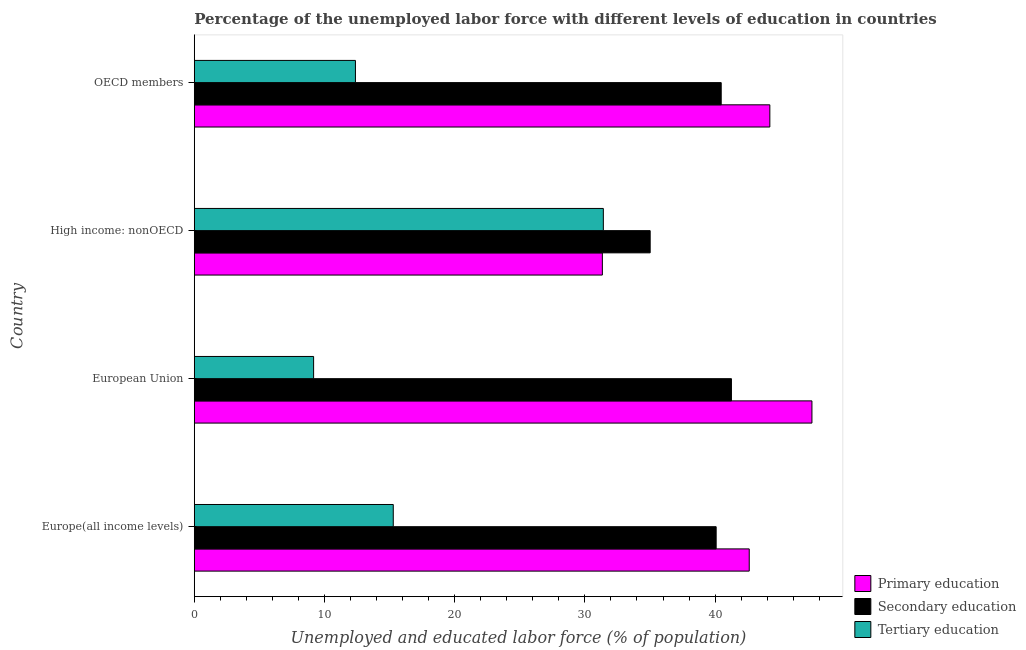How many groups of bars are there?
Ensure brevity in your answer.  4. Are the number of bars per tick equal to the number of legend labels?
Offer a very short reply. Yes. Are the number of bars on each tick of the Y-axis equal?
Provide a succinct answer. Yes. How many bars are there on the 4th tick from the bottom?
Make the answer very short. 3. What is the label of the 3rd group of bars from the top?
Your response must be concise. European Union. In how many cases, is the number of bars for a given country not equal to the number of legend labels?
Provide a succinct answer. 0. What is the percentage of labor force who received primary education in European Union?
Make the answer very short. 47.44. Across all countries, what is the maximum percentage of labor force who received secondary education?
Ensure brevity in your answer.  41.26. Across all countries, what is the minimum percentage of labor force who received primary education?
Ensure brevity in your answer.  31.34. In which country was the percentage of labor force who received tertiary education maximum?
Ensure brevity in your answer.  High income: nonOECD. In which country was the percentage of labor force who received secondary education minimum?
Provide a succinct answer. High income: nonOECD. What is the total percentage of labor force who received secondary education in the graph?
Offer a terse response. 156.83. What is the difference between the percentage of labor force who received tertiary education in European Union and that in OECD members?
Your answer should be very brief. -3.21. What is the difference between the percentage of labor force who received secondary education in Europe(all income levels) and the percentage of labor force who received tertiary education in European Union?
Your answer should be compact. 30.92. What is the average percentage of labor force who received primary education per country?
Provide a succinct answer. 41.4. What is the difference between the percentage of labor force who received secondary education and percentage of labor force who received primary education in OECD members?
Keep it short and to the point. -3.74. What is the ratio of the percentage of labor force who received tertiary education in Europe(all income levels) to that in European Union?
Keep it short and to the point. 1.67. Is the difference between the percentage of labor force who received secondary education in High income: nonOECD and OECD members greater than the difference between the percentage of labor force who received tertiary education in High income: nonOECD and OECD members?
Your answer should be compact. No. What is the difference between the highest and the second highest percentage of labor force who received primary education?
Make the answer very short. 3.23. What is the difference between the highest and the lowest percentage of labor force who received tertiary education?
Ensure brevity in your answer.  22.25. In how many countries, is the percentage of labor force who received tertiary education greater than the average percentage of labor force who received tertiary education taken over all countries?
Give a very brief answer. 1. Is the sum of the percentage of labor force who received primary education in High income: nonOECD and OECD members greater than the maximum percentage of labor force who received secondary education across all countries?
Ensure brevity in your answer.  Yes. What does the 2nd bar from the top in High income: nonOECD represents?
Provide a succinct answer. Secondary education. What does the 3rd bar from the bottom in OECD members represents?
Your answer should be compact. Tertiary education. Is it the case that in every country, the sum of the percentage of labor force who received primary education and percentage of labor force who received secondary education is greater than the percentage of labor force who received tertiary education?
Provide a short and direct response. Yes. How many bars are there?
Provide a short and direct response. 12. Are all the bars in the graph horizontal?
Provide a succinct answer. Yes. How many countries are there in the graph?
Keep it short and to the point. 4. What is the difference between two consecutive major ticks on the X-axis?
Offer a very short reply. 10. Are the values on the major ticks of X-axis written in scientific E-notation?
Offer a very short reply. No. Does the graph contain any zero values?
Keep it short and to the point. No. How many legend labels are there?
Make the answer very short. 3. How are the legend labels stacked?
Give a very brief answer. Vertical. What is the title of the graph?
Ensure brevity in your answer.  Percentage of the unemployed labor force with different levels of education in countries. What is the label or title of the X-axis?
Offer a terse response. Unemployed and educated labor force (% of population). What is the label or title of the Y-axis?
Your answer should be compact. Country. What is the Unemployed and educated labor force (% of population) of Primary education in Europe(all income levels)?
Ensure brevity in your answer.  42.62. What is the Unemployed and educated labor force (% of population) in Secondary education in Europe(all income levels)?
Provide a succinct answer. 40.08. What is the Unemployed and educated labor force (% of population) in Tertiary education in Europe(all income levels)?
Offer a very short reply. 15.28. What is the Unemployed and educated labor force (% of population) in Primary education in European Union?
Give a very brief answer. 47.44. What is the Unemployed and educated labor force (% of population) of Secondary education in European Union?
Your response must be concise. 41.26. What is the Unemployed and educated labor force (% of population) of Tertiary education in European Union?
Your response must be concise. 9.17. What is the Unemployed and educated labor force (% of population) of Primary education in High income: nonOECD?
Keep it short and to the point. 31.34. What is the Unemployed and educated labor force (% of population) of Secondary education in High income: nonOECD?
Ensure brevity in your answer.  35.02. What is the Unemployed and educated labor force (% of population) of Tertiary education in High income: nonOECD?
Make the answer very short. 31.42. What is the Unemployed and educated labor force (% of population) in Primary education in OECD members?
Provide a short and direct response. 44.21. What is the Unemployed and educated labor force (% of population) of Secondary education in OECD members?
Provide a succinct answer. 40.47. What is the Unemployed and educated labor force (% of population) of Tertiary education in OECD members?
Give a very brief answer. 12.38. Across all countries, what is the maximum Unemployed and educated labor force (% of population) in Primary education?
Keep it short and to the point. 47.44. Across all countries, what is the maximum Unemployed and educated labor force (% of population) in Secondary education?
Your answer should be compact. 41.26. Across all countries, what is the maximum Unemployed and educated labor force (% of population) in Tertiary education?
Provide a short and direct response. 31.42. Across all countries, what is the minimum Unemployed and educated labor force (% of population) in Primary education?
Ensure brevity in your answer.  31.34. Across all countries, what is the minimum Unemployed and educated labor force (% of population) in Secondary education?
Your response must be concise. 35.02. Across all countries, what is the minimum Unemployed and educated labor force (% of population) in Tertiary education?
Keep it short and to the point. 9.17. What is the total Unemployed and educated labor force (% of population) in Primary education in the graph?
Your response must be concise. 165.61. What is the total Unemployed and educated labor force (% of population) of Secondary education in the graph?
Keep it short and to the point. 156.83. What is the total Unemployed and educated labor force (% of population) of Tertiary education in the graph?
Offer a terse response. 68.25. What is the difference between the Unemployed and educated labor force (% of population) of Primary education in Europe(all income levels) and that in European Union?
Your response must be concise. -4.82. What is the difference between the Unemployed and educated labor force (% of population) of Secondary education in Europe(all income levels) and that in European Union?
Give a very brief answer. -1.17. What is the difference between the Unemployed and educated labor force (% of population) of Tertiary education in Europe(all income levels) and that in European Union?
Offer a very short reply. 6.12. What is the difference between the Unemployed and educated labor force (% of population) in Primary education in Europe(all income levels) and that in High income: nonOECD?
Ensure brevity in your answer.  11.28. What is the difference between the Unemployed and educated labor force (% of population) in Secondary education in Europe(all income levels) and that in High income: nonOECD?
Your answer should be very brief. 5.07. What is the difference between the Unemployed and educated labor force (% of population) in Tertiary education in Europe(all income levels) and that in High income: nonOECD?
Provide a short and direct response. -16.14. What is the difference between the Unemployed and educated labor force (% of population) in Primary education in Europe(all income levels) and that in OECD members?
Ensure brevity in your answer.  -1.58. What is the difference between the Unemployed and educated labor force (% of population) in Secondary education in Europe(all income levels) and that in OECD members?
Provide a short and direct response. -0.39. What is the difference between the Unemployed and educated labor force (% of population) of Tertiary education in Europe(all income levels) and that in OECD members?
Ensure brevity in your answer.  2.91. What is the difference between the Unemployed and educated labor force (% of population) of Primary education in European Union and that in High income: nonOECD?
Offer a very short reply. 16.1. What is the difference between the Unemployed and educated labor force (% of population) in Secondary education in European Union and that in High income: nonOECD?
Provide a short and direct response. 6.24. What is the difference between the Unemployed and educated labor force (% of population) of Tertiary education in European Union and that in High income: nonOECD?
Keep it short and to the point. -22.25. What is the difference between the Unemployed and educated labor force (% of population) of Primary education in European Union and that in OECD members?
Your answer should be very brief. 3.23. What is the difference between the Unemployed and educated labor force (% of population) in Secondary education in European Union and that in OECD members?
Offer a very short reply. 0.79. What is the difference between the Unemployed and educated labor force (% of population) in Tertiary education in European Union and that in OECD members?
Provide a succinct answer. -3.21. What is the difference between the Unemployed and educated labor force (% of population) of Primary education in High income: nonOECD and that in OECD members?
Keep it short and to the point. -12.86. What is the difference between the Unemployed and educated labor force (% of population) of Secondary education in High income: nonOECD and that in OECD members?
Provide a short and direct response. -5.46. What is the difference between the Unemployed and educated labor force (% of population) in Tertiary education in High income: nonOECD and that in OECD members?
Provide a succinct answer. 19.04. What is the difference between the Unemployed and educated labor force (% of population) of Primary education in Europe(all income levels) and the Unemployed and educated labor force (% of population) of Secondary education in European Union?
Your answer should be compact. 1.37. What is the difference between the Unemployed and educated labor force (% of population) of Primary education in Europe(all income levels) and the Unemployed and educated labor force (% of population) of Tertiary education in European Union?
Provide a short and direct response. 33.46. What is the difference between the Unemployed and educated labor force (% of population) of Secondary education in Europe(all income levels) and the Unemployed and educated labor force (% of population) of Tertiary education in European Union?
Offer a very short reply. 30.92. What is the difference between the Unemployed and educated labor force (% of population) of Primary education in Europe(all income levels) and the Unemployed and educated labor force (% of population) of Secondary education in High income: nonOECD?
Give a very brief answer. 7.61. What is the difference between the Unemployed and educated labor force (% of population) in Primary education in Europe(all income levels) and the Unemployed and educated labor force (% of population) in Tertiary education in High income: nonOECD?
Your answer should be very brief. 11.2. What is the difference between the Unemployed and educated labor force (% of population) of Secondary education in Europe(all income levels) and the Unemployed and educated labor force (% of population) of Tertiary education in High income: nonOECD?
Make the answer very short. 8.66. What is the difference between the Unemployed and educated labor force (% of population) in Primary education in Europe(all income levels) and the Unemployed and educated labor force (% of population) in Secondary education in OECD members?
Your answer should be compact. 2.15. What is the difference between the Unemployed and educated labor force (% of population) in Primary education in Europe(all income levels) and the Unemployed and educated labor force (% of population) in Tertiary education in OECD members?
Offer a terse response. 30.25. What is the difference between the Unemployed and educated labor force (% of population) in Secondary education in Europe(all income levels) and the Unemployed and educated labor force (% of population) in Tertiary education in OECD members?
Your answer should be compact. 27.7. What is the difference between the Unemployed and educated labor force (% of population) of Primary education in European Union and the Unemployed and educated labor force (% of population) of Secondary education in High income: nonOECD?
Your answer should be very brief. 12.42. What is the difference between the Unemployed and educated labor force (% of population) in Primary education in European Union and the Unemployed and educated labor force (% of population) in Tertiary education in High income: nonOECD?
Offer a terse response. 16.02. What is the difference between the Unemployed and educated labor force (% of population) in Secondary education in European Union and the Unemployed and educated labor force (% of population) in Tertiary education in High income: nonOECD?
Give a very brief answer. 9.84. What is the difference between the Unemployed and educated labor force (% of population) of Primary education in European Union and the Unemployed and educated labor force (% of population) of Secondary education in OECD members?
Keep it short and to the point. 6.97. What is the difference between the Unemployed and educated labor force (% of population) in Primary education in European Union and the Unemployed and educated labor force (% of population) in Tertiary education in OECD members?
Keep it short and to the point. 35.06. What is the difference between the Unemployed and educated labor force (% of population) of Secondary education in European Union and the Unemployed and educated labor force (% of population) of Tertiary education in OECD members?
Give a very brief answer. 28.88. What is the difference between the Unemployed and educated labor force (% of population) in Primary education in High income: nonOECD and the Unemployed and educated labor force (% of population) in Secondary education in OECD members?
Keep it short and to the point. -9.13. What is the difference between the Unemployed and educated labor force (% of population) in Primary education in High income: nonOECD and the Unemployed and educated labor force (% of population) in Tertiary education in OECD members?
Offer a terse response. 18.97. What is the difference between the Unemployed and educated labor force (% of population) of Secondary education in High income: nonOECD and the Unemployed and educated labor force (% of population) of Tertiary education in OECD members?
Offer a very short reply. 22.64. What is the average Unemployed and educated labor force (% of population) in Primary education per country?
Your response must be concise. 41.4. What is the average Unemployed and educated labor force (% of population) in Secondary education per country?
Your answer should be compact. 39.21. What is the average Unemployed and educated labor force (% of population) of Tertiary education per country?
Offer a very short reply. 17.06. What is the difference between the Unemployed and educated labor force (% of population) in Primary education and Unemployed and educated labor force (% of population) in Secondary education in Europe(all income levels)?
Offer a terse response. 2.54. What is the difference between the Unemployed and educated labor force (% of population) in Primary education and Unemployed and educated labor force (% of population) in Tertiary education in Europe(all income levels)?
Provide a short and direct response. 27.34. What is the difference between the Unemployed and educated labor force (% of population) in Secondary education and Unemployed and educated labor force (% of population) in Tertiary education in Europe(all income levels)?
Your answer should be very brief. 24.8. What is the difference between the Unemployed and educated labor force (% of population) in Primary education and Unemployed and educated labor force (% of population) in Secondary education in European Union?
Provide a short and direct response. 6.18. What is the difference between the Unemployed and educated labor force (% of population) of Primary education and Unemployed and educated labor force (% of population) of Tertiary education in European Union?
Ensure brevity in your answer.  38.27. What is the difference between the Unemployed and educated labor force (% of population) in Secondary education and Unemployed and educated labor force (% of population) in Tertiary education in European Union?
Your answer should be compact. 32.09. What is the difference between the Unemployed and educated labor force (% of population) of Primary education and Unemployed and educated labor force (% of population) of Secondary education in High income: nonOECD?
Make the answer very short. -3.67. What is the difference between the Unemployed and educated labor force (% of population) of Primary education and Unemployed and educated labor force (% of population) of Tertiary education in High income: nonOECD?
Provide a short and direct response. -0.08. What is the difference between the Unemployed and educated labor force (% of population) of Secondary education and Unemployed and educated labor force (% of population) of Tertiary education in High income: nonOECD?
Your response must be concise. 3.6. What is the difference between the Unemployed and educated labor force (% of population) in Primary education and Unemployed and educated labor force (% of population) in Secondary education in OECD members?
Your response must be concise. 3.74. What is the difference between the Unemployed and educated labor force (% of population) in Primary education and Unemployed and educated labor force (% of population) in Tertiary education in OECD members?
Keep it short and to the point. 31.83. What is the difference between the Unemployed and educated labor force (% of population) in Secondary education and Unemployed and educated labor force (% of population) in Tertiary education in OECD members?
Ensure brevity in your answer.  28.09. What is the ratio of the Unemployed and educated labor force (% of population) of Primary education in Europe(all income levels) to that in European Union?
Provide a succinct answer. 0.9. What is the ratio of the Unemployed and educated labor force (% of population) in Secondary education in Europe(all income levels) to that in European Union?
Keep it short and to the point. 0.97. What is the ratio of the Unemployed and educated labor force (% of population) of Tertiary education in Europe(all income levels) to that in European Union?
Keep it short and to the point. 1.67. What is the ratio of the Unemployed and educated labor force (% of population) of Primary education in Europe(all income levels) to that in High income: nonOECD?
Your answer should be compact. 1.36. What is the ratio of the Unemployed and educated labor force (% of population) of Secondary education in Europe(all income levels) to that in High income: nonOECD?
Offer a very short reply. 1.14. What is the ratio of the Unemployed and educated labor force (% of population) of Tertiary education in Europe(all income levels) to that in High income: nonOECD?
Your answer should be very brief. 0.49. What is the ratio of the Unemployed and educated labor force (% of population) in Primary education in Europe(all income levels) to that in OECD members?
Your answer should be compact. 0.96. What is the ratio of the Unemployed and educated labor force (% of population) of Tertiary education in Europe(all income levels) to that in OECD members?
Your answer should be very brief. 1.23. What is the ratio of the Unemployed and educated labor force (% of population) of Primary education in European Union to that in High income: nonOECD?
Provide a succinct answer. 1.51. What is the ratio of the Unemployed and educated labor force (% of population) in Secondary education in European Union to that in High income: nonOECD?
Your answer should be compact. 1.18. What is the ratio of the Unemployed and educated labor force (% of population) of Tertiary education in European Union to that in High income: nonOECD?
Provide a short and direct response. 0.29. What is the ratio of the Unemployed and educated labor force (% of population) in Primary education in European Union to that in OECD members?
Ensure brevity in your answer.  1.07. What is the ratio of the Unemployed and educated labor force (% of population) of Secondary education in European Union to that in OECD members?
Offer a very short reply. 1.02. What is the ratio of the Unemployed and educated labor force (% of population) of Tertiary education in European Union to that in OECD members?
Your answer should be very brief. 0.74. What is the ratio of the Unemployed and educated labor force (% of population) of Primary education in High income: nonOECD to that in OECD members?
Provide a short and direct response. 0.71. What is the ratio of the Unemployed and educated labor force (% of population) of Secondary education in High income: nonOECD to that in OECD members?
Offer a terse response. 0.87. What is the ratio of the Unemployed and educated labor force (% of population) of Tertiary education in High income: nonOECD to that in OECD members?
Make the answer very short. 2.54. What is the difference between the highest and the second highest Unemployed and educated labor force (% of population) of Primary education?
Provide a short and direct response. 3.23. What is the difference between the highest and the second highest Unemployed and educated labor force (% of population) in Secondary education?
Your answer should be very brief. 0.79. What is the difference between the highest and the second highest Unemployed and educated labor force (% of population) of Tertiary education?
Your response must be concise. 16.14. What is the difference between the highest and the lowest Unemployed and educated labor force (% of population) in Primary education?
Give a very brief answer. 16.1. What is the difference between the highest and the lowest Unemployed and educated labor force (% of population) of Secondary education?
Give a very brief answer. 6.24. What is the difference between the highest and the lowest Unemployed and educated labor force (% of population) in Tertiary education?
Give a very brief answer. 22.25. 